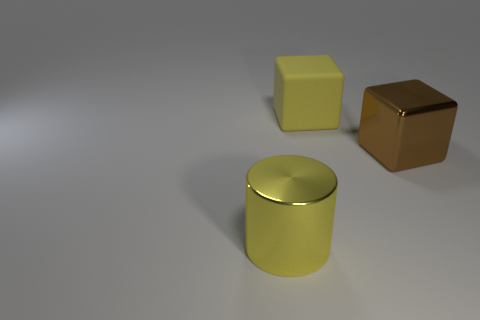There is a thing that is the same color as the big rubber block; what is its size? The object that shares the color with the large rubber block appears to be a cylindrical container, and its size is medium compared to the block, suggesting a moderate volume capacity. Its dimensions are less than the block in height but similar in diameter, indicating it is sizable but not as large as the block. 